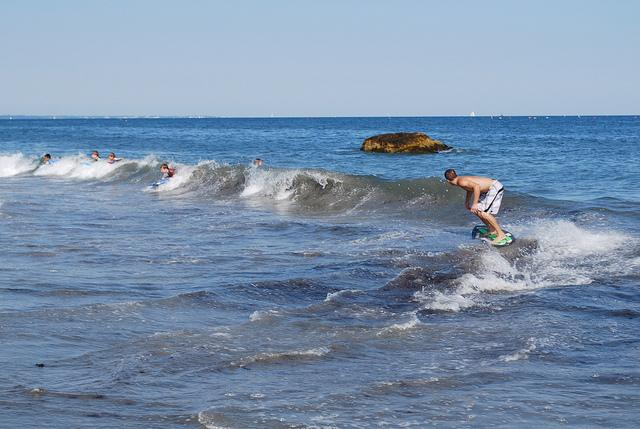Who is the most famous surfer?

Choices:
A) duke
B) nick
C) laird
D) miki dora duke 